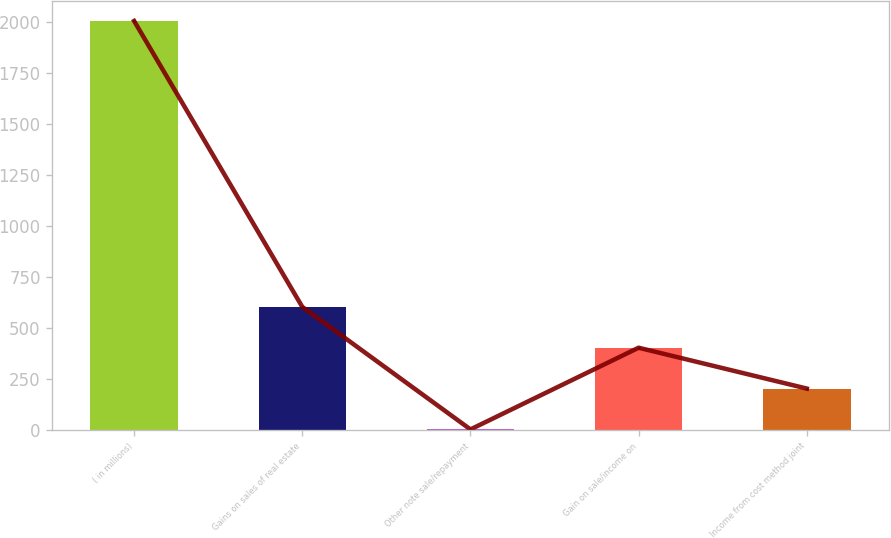<chart> <loc_0><loc_0><loc_500><loc_500><bar_chart><fcel>( in millions)<fcel>Gains on sales of real estate<fcel>Other note sale/repayment<fcel>Gain on sale/income on<fcel>Income from cost method joint<nl><fcel>2007<fcel>602.8<fcel>1<fcel>402.2<fcel>201.6<nl></chart> 